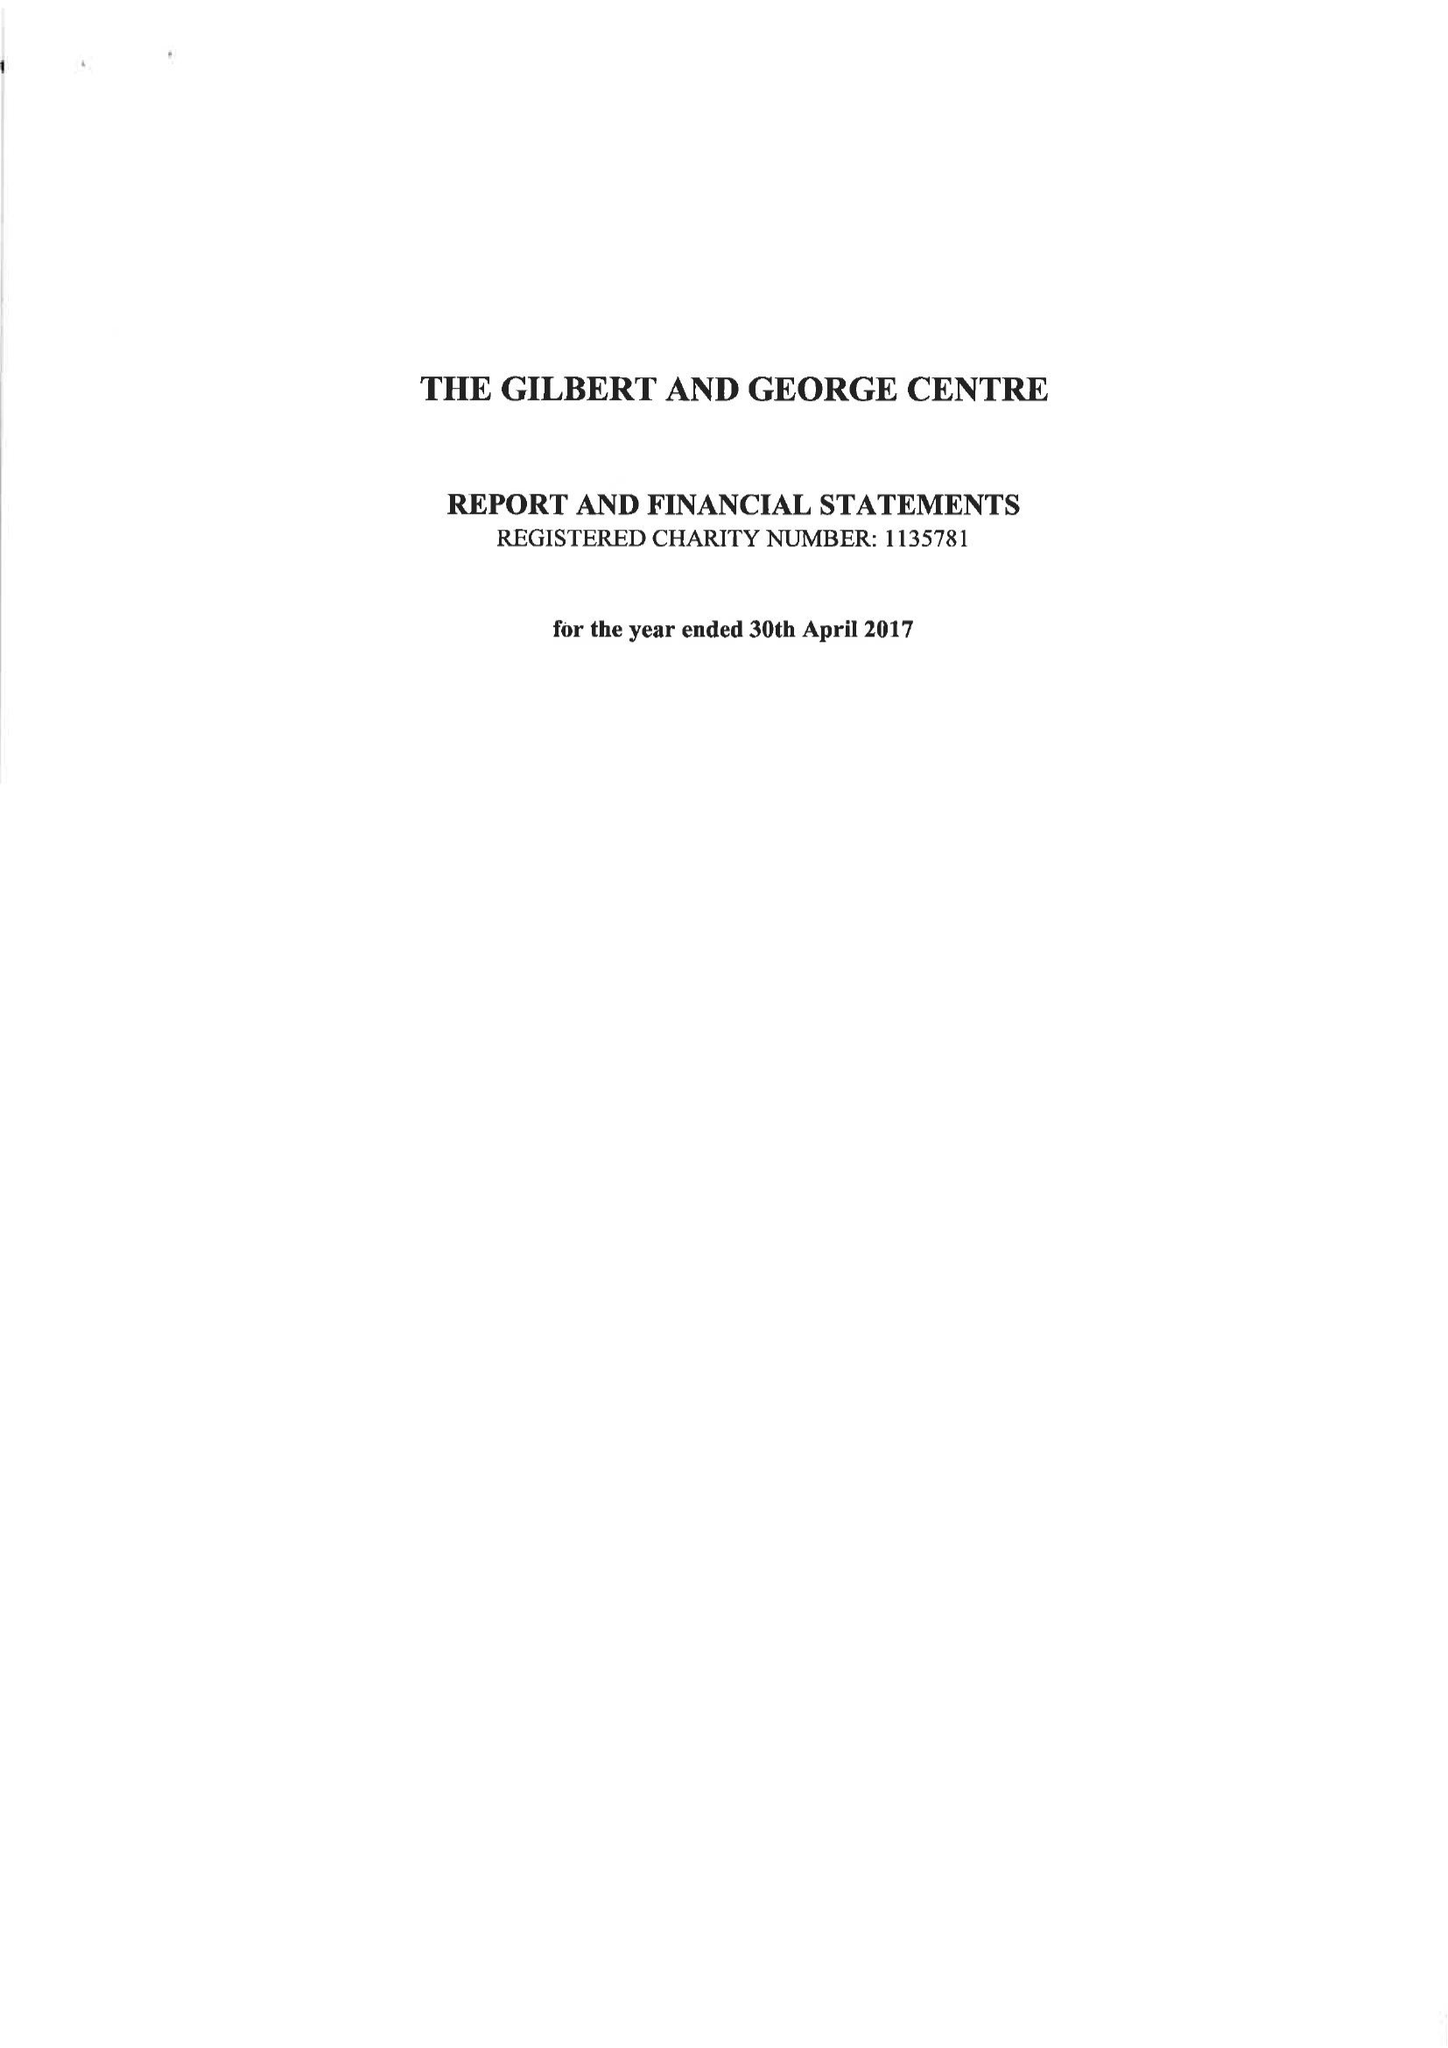What is the value for the address__post_town?
Answer the question using a single word or phrase. LONDON 